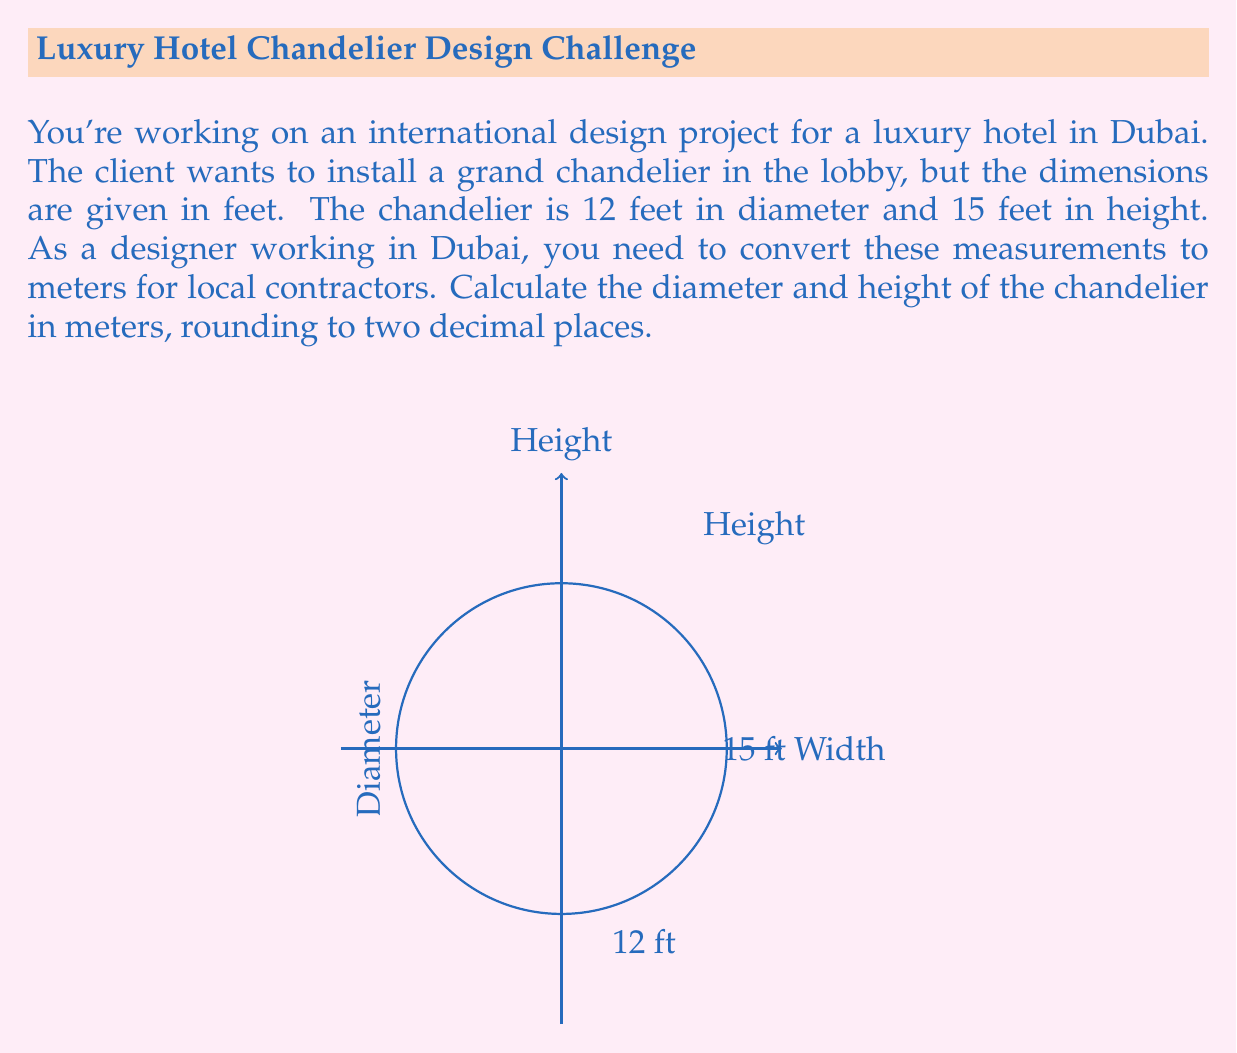Help me with this question. To solve this problem, we need to convert feet to meters. The conversion factor is:

1 foot = 0.3048 meters

Let's convert each dimension:

1. Diameter:
   $12 \text{ feet} \times 0.3048 \text{ m/ft} = 3.6576 \text{ m}$
   Rounding to two decimal places: 3.66 m

2. Height:
   $15 \text{ feet} \times 0.3048 \text{ m/ft} = 4.572 \text{ m}$
   Rounding to two decimal places: 4.57 m

The conversion can also be represented as a general formula:

$$\text{Measurement in meters} = \text{Measurement in feet} \times 0.3048$$

Using this formula ensures accurate conversion for any given measurement in feet.
Answer: Diameter: 3.66 m, Height: 4.57 m 